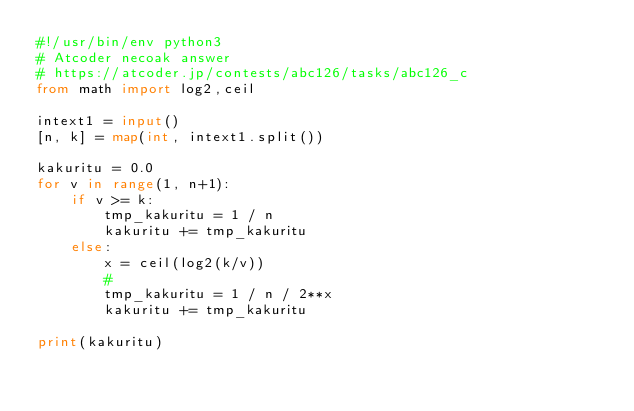<code> <loc_0><loc_0><loc_500><loc_500><_Python_>#!/usr/bin/env python3
# Atcoder necoak answer
# https://atcoder.jp/contests/abc126/tasks/abc126_c
from math import log2,ceil

intext1 = input()
[n, k] = map(int, intext1.split())

kakuritu = 0.0
for v in range(1, n+1):
    if v >= k:
        tmp_kakuritu = 1 / n
        kakuritu += tmp_kakuritu
    else:
        x = ceil(log2(k/v))
        #
        tmp_kakuritu = 1 / n / 2**x
        kakuritu += tmp_kakuritu

print(kakuritu)
</code> 